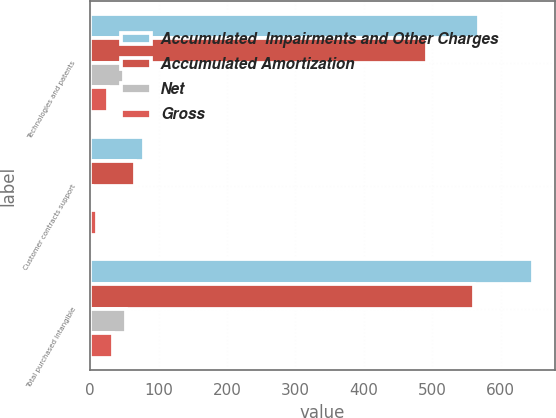Convert chart. <chart><loc_0><loc_0><loc_500><loc_500><stacked_bar_chart><ecel><fcel>Technologies and patents<fcel>Customer contracts support<fcel>Total purchased intangible<nl><fcel>Accumulated  Impairments and Other Charges<fcel>567.7<fcel>78.1<fcel>646.9<nl><fcel>Accumulated Amortization<fcel>491.8<fcel>65.2<fcel>560.3<nl><fcel>Net<fcel>49.9<fcel>2.8<fcel>52.7<nl><fcel>Gross<fcel>26<fcel>10.1<fcel>33.9<nl></chart> 